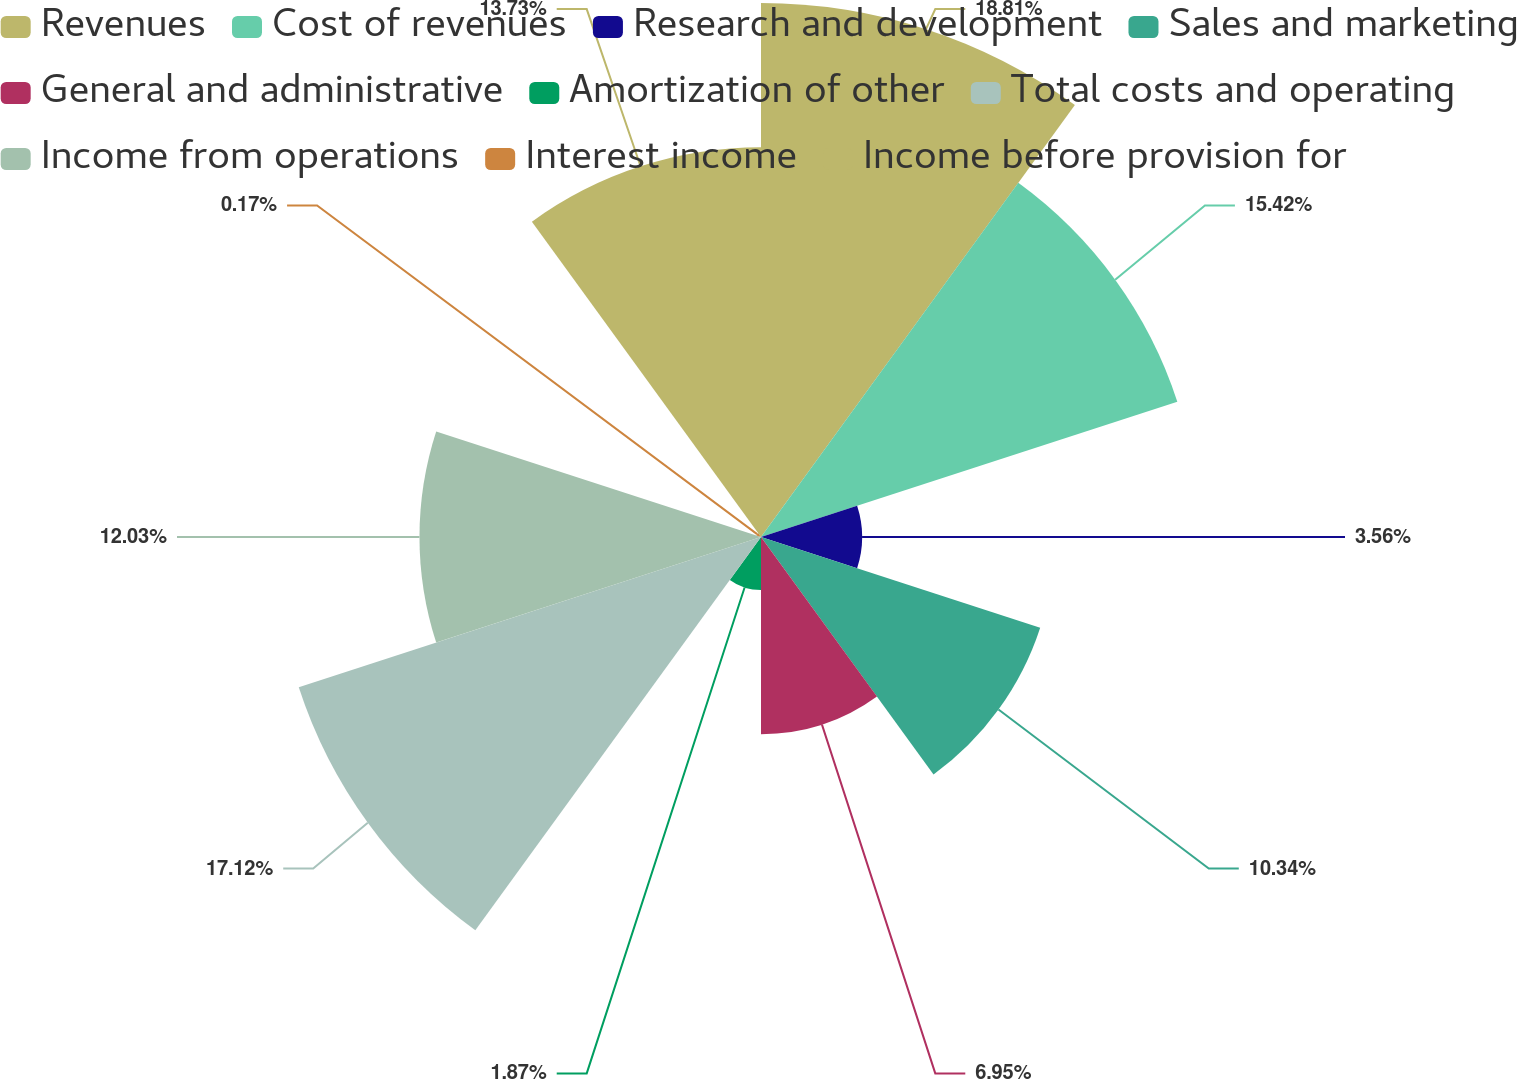Convert chart. <chart><loc_0><loc_0><loc_500><loc_500><pie_chart><fcel>Revenues<fcel>Cost of revenues<fcel>Research and development<fcel>Sales and marketing<fcel>General and administrative<fcel>Amortization of other<fcel>Total costs and operating<fcel>Income from operations<fcel>Interest income<fcel>Income before provision for<nl><fcel>18.81%<fcel>15.42%<fcel>3.56%<fcel>10.34%<fcel>6.95%<fcel>1.87%<fcel>17.12%<fcel>12.03%<fcel>0.17%<fcel>13.73%<nl></chart> 